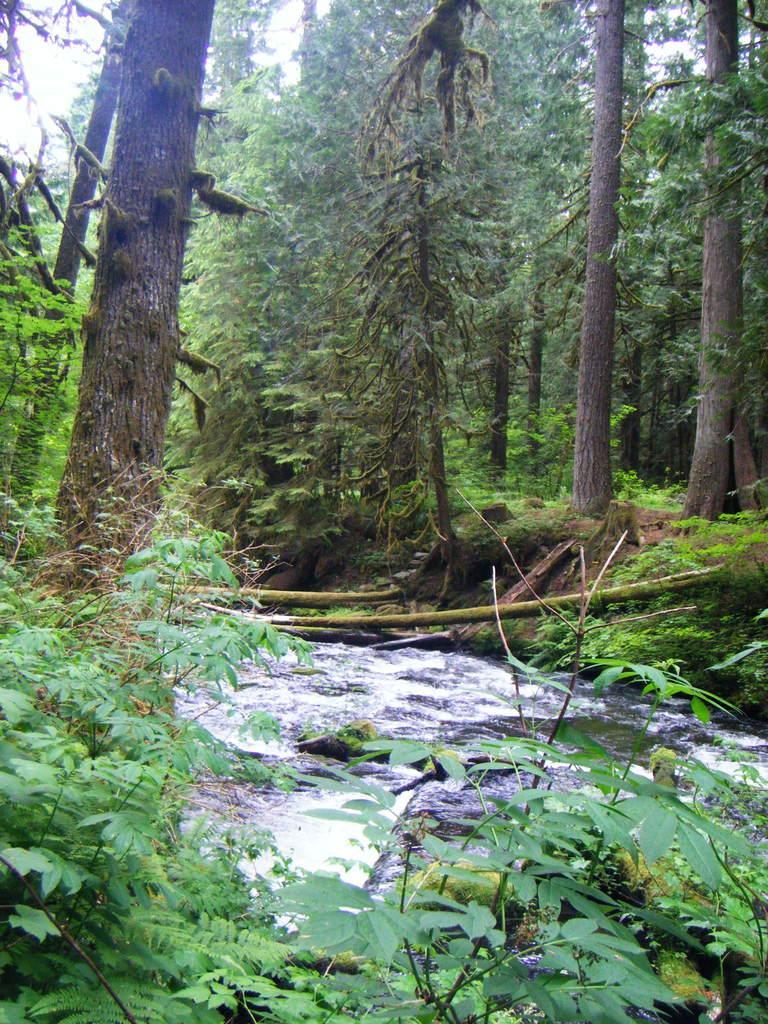How would you summarize this image in a sentence or two? In this image there are trees, in the middle of them there is water flow and in the background there is the sky. 